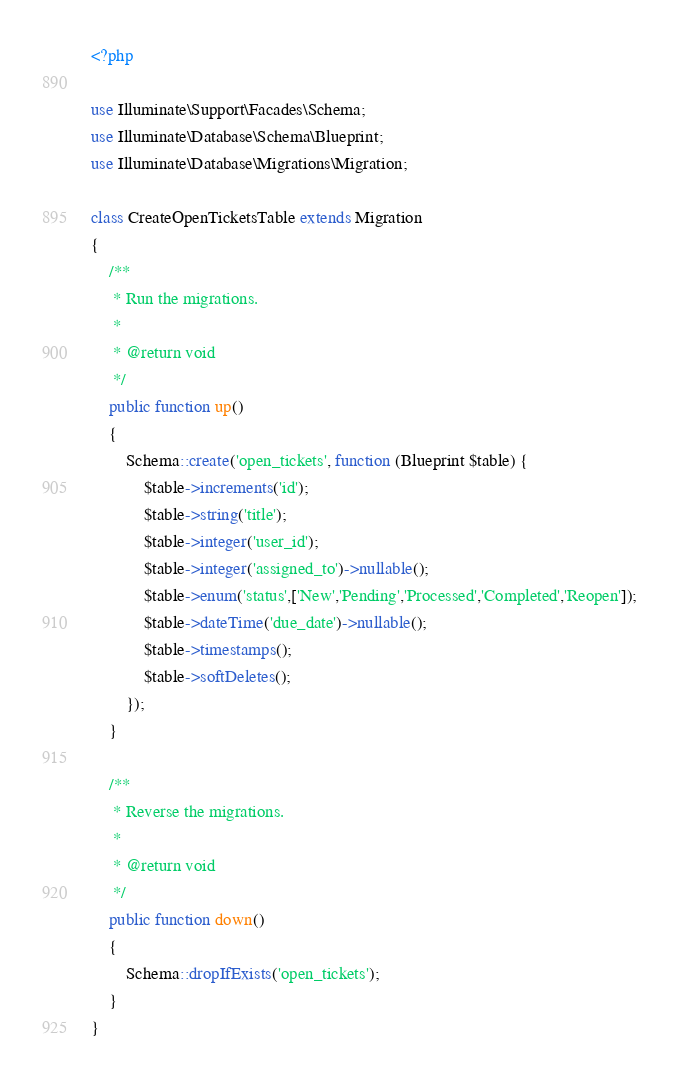Convert code to text. <code><loc_0><loc_0><loc_500><loc_500><_PHP_><?php

use Illuminate\Support\Facades\Schema;
use Illuminate\Database\Schema\Blueprint;
use Illuminate\Database\Migrations\Migration;

class CreateOpenTicketsTable extends Migration
{
    /**
     * Run the migrations.
     *
     * @return void
     */
    public function up()
    {
        Schema::create('open_tickets', function (Blueprint $table) {
            $table->increments('id');
            $table->string('title');
            $table->integer('user_id');
            $table->integer('assigned_to')->nullable();
            $table->enum('status',['New','Pending','Processed','Completed','Reopen']);
            $table->dateTime('due_date')->nullable();
            $table->timestamps();
            $table->softDeletes();
        });
    }

    /**
     * Reverse the migrations.
     *
     * @return void
     */
    public function down()
    {
        Schema::dropIfExists('open_tickets');
    }
}
</code> 